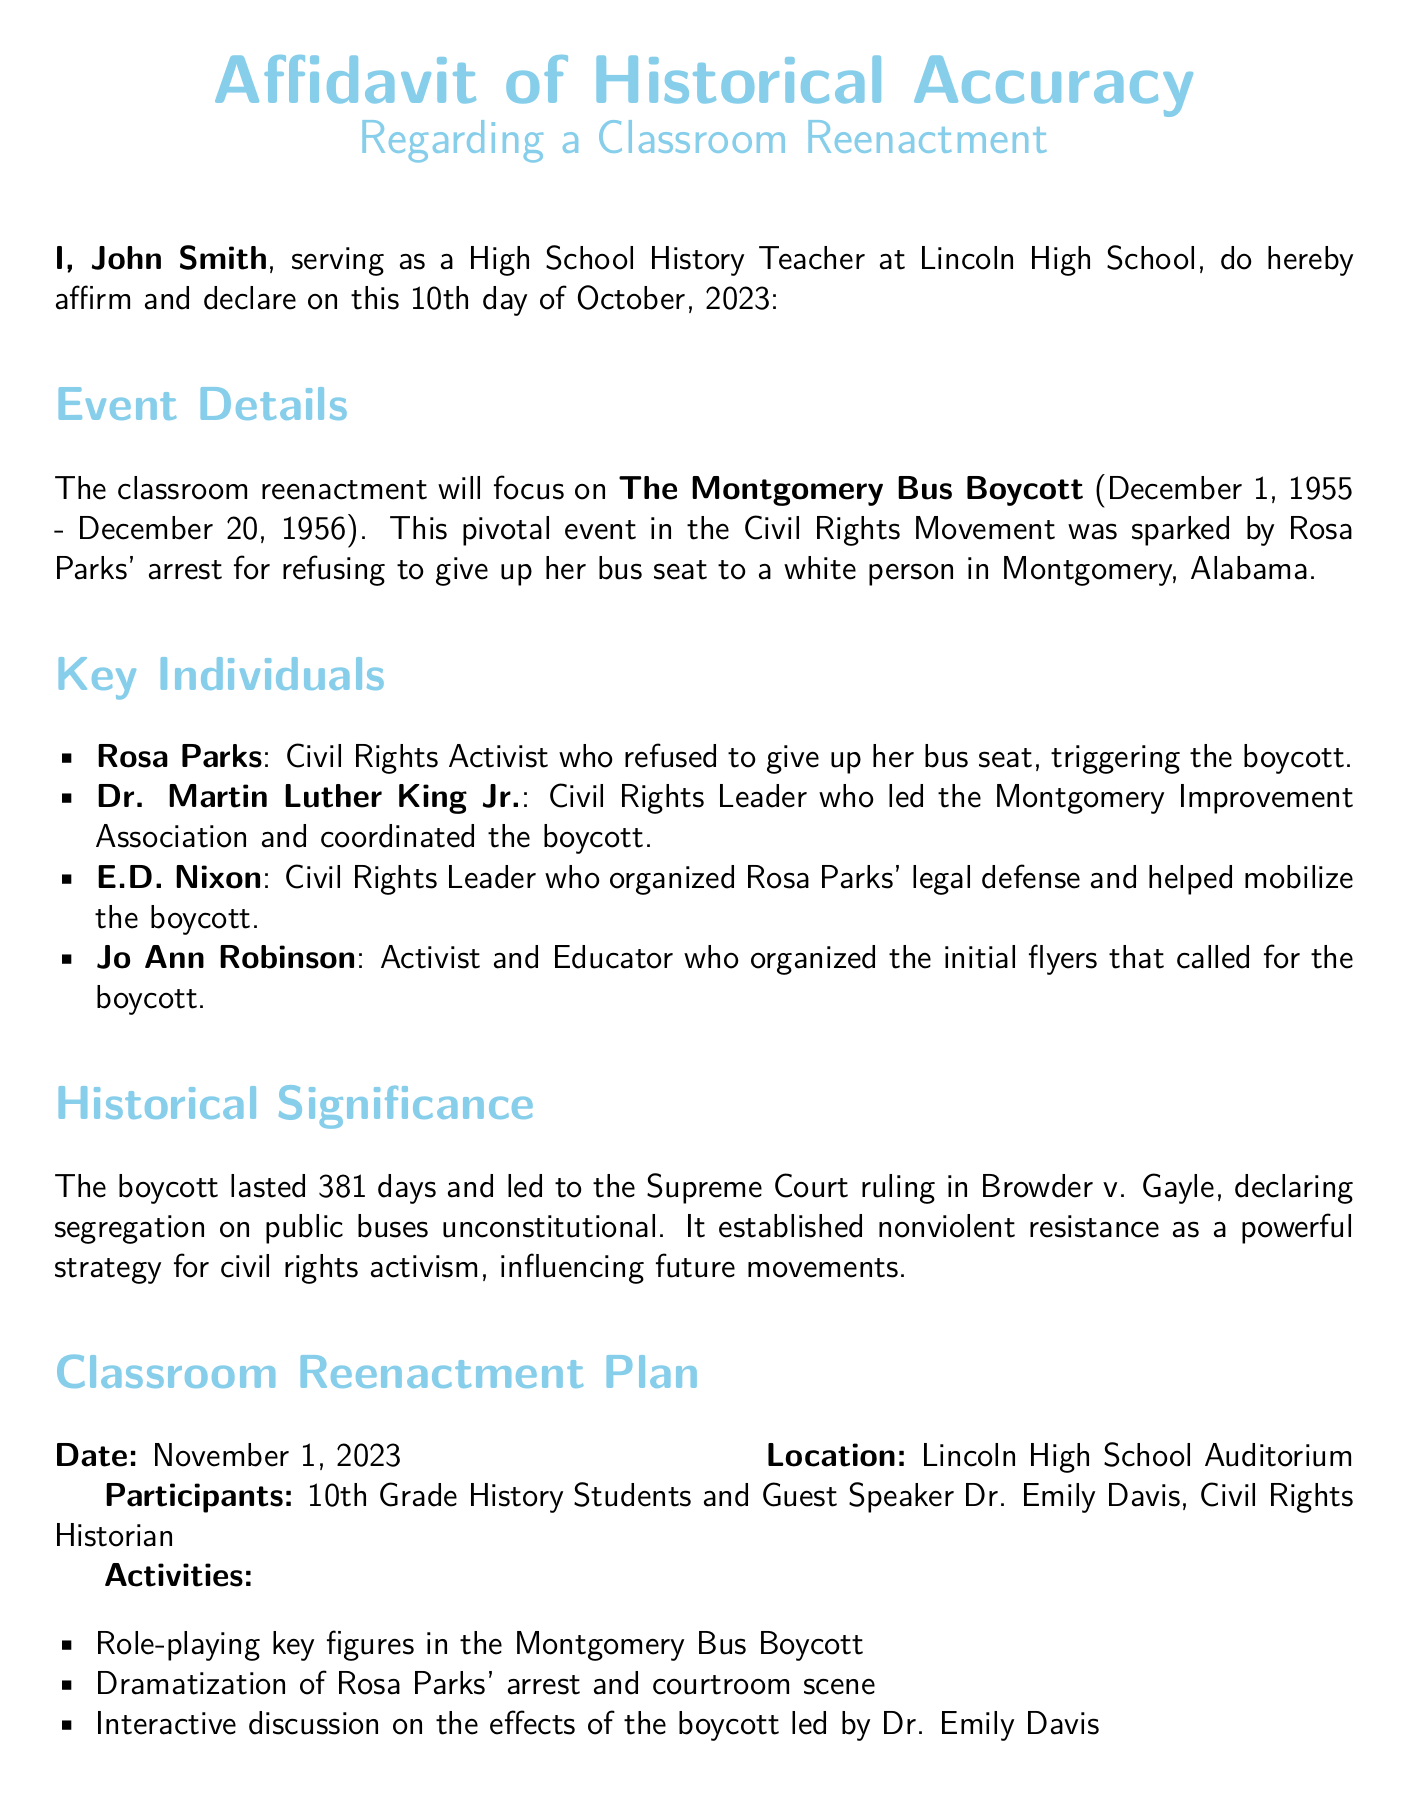What is the title of the document? The title is explicitly mentioned at the beginning of the document as "Affidavit of Historical Accuracy."
Answer: Affidavit of Historical Accuracy Who is the author of this affidavit? The author introduces himself as John Smith, a High School History Teacher.
Answer: John Smith What event is the reenactment focused on? The document specifies that the reenactment will focus on "The Montgomery Bus Boycott."
Answer: The Montgomery Bus Boycott When did the Montgomery Bus Boycott take place? The timeframe for the boycott is provided in the document as December 1, 1955 - December 20, 1956.
Answer: December 1, 1955 - December 20, 1956 How long did the boycott last? The document states that the boycott lasted for 381 days.
Answer: 381 days Who served as a guest speaker for the reenactment? The guest speaker's name is listed as Dr. Emily Davis, a Civil Rights Historian.
Answer: Dr. Emily Davis What was a key outcome of the Montgomery Bus Boycott? The document mentions the Supreme Court ruling in Browder v. Gayle as a key outcome that declared segregation on public buses unconstitutional.
Answer: Browder v. Gayle What significant strategy for civil rights activism was established by the boycott? The document notes that the boycott established "nonviolent resistance" as a powerful strategy for civil rights activism.
Answer: Nonviolent resistance What date is the classroom reenactment scheduled for? The date for the reenactment is clearly stated in the document as November 1, 2023.
Answer: November 1, 2023 What type of activities are planned for the reenactment? A list of activities is provided, including role-playing, dramatization, and an interactive discussion.
Answer: Role-playing, dramatization, and interactive discussion 